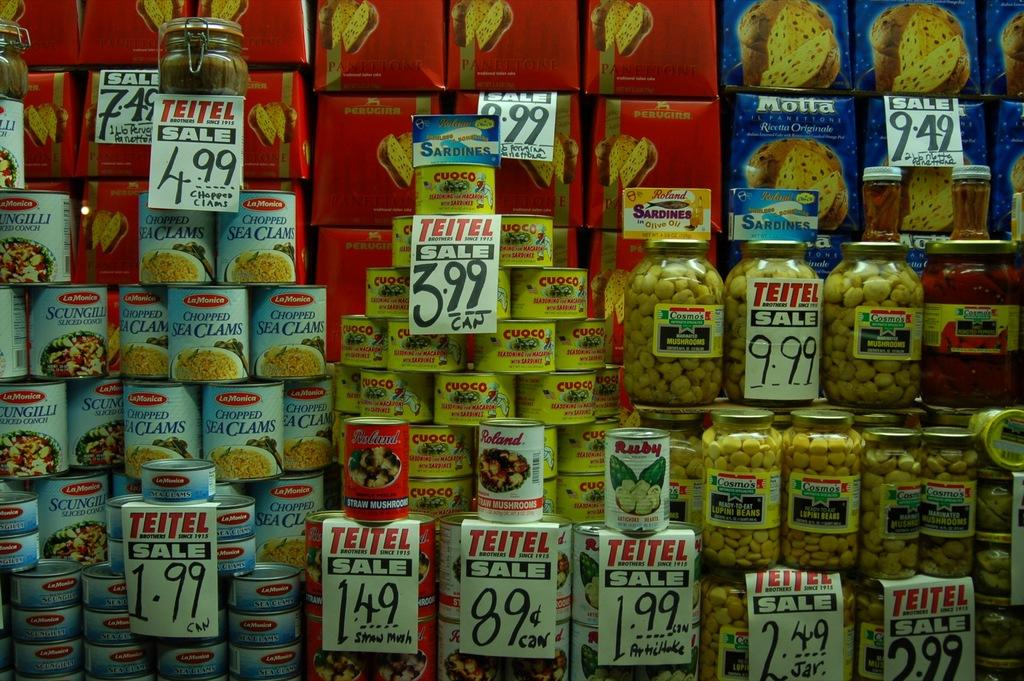<image>
Share a concise interpretation of the image provided. Several grocery products boast price labels for the brand Teitel, which is on sale. 